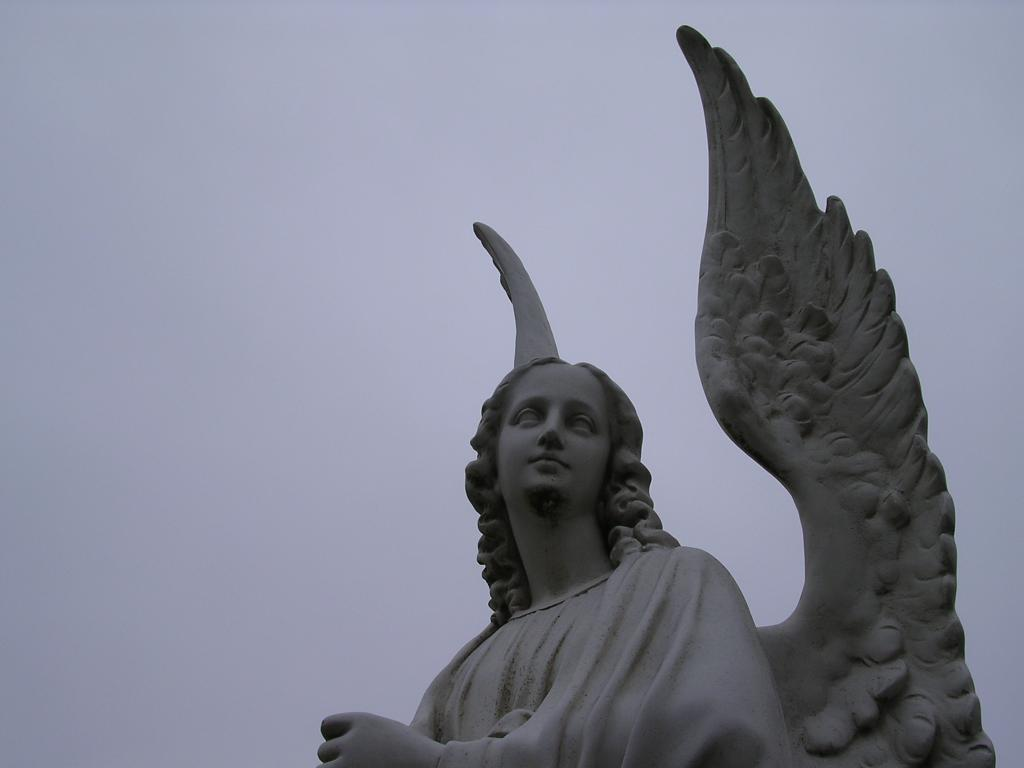What is the main subject of the image? The main subject of the image is a statue of a girl. What distinguishing feature does the girl statue have? The girl statue has wings. What is visible at the top of the image? The sky is visible at the top of the image. What type of wax can be seen melting on the girl statue's wings in the image? There is no wax present on the girl statue's wings in the image. What color is the chalk drawing of the girl statue's part in the image? There is no chalk drawing or any indication of a "part" in the image; it features a statue of a girl with wings. 